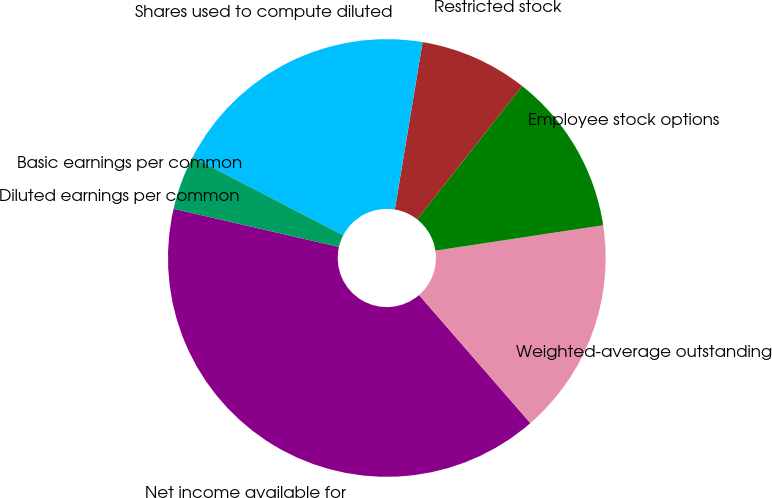Convert chart to OTSL. <chart><loc_0><loc_0><loc_500><loc_500><pie_chart><fcel>Net income available for<fcel>Weighted-average outstanding<fcel>Employee stock options<fcel>Restricted stock<fcel>Shares used to compute diluted<fcel>Basic earnings per common<fcel>Diluted earnings per common<nl><fcel>40.0%<fcel>16.0%<fcel>12.0%<fcel>8.0%<fcel>20.0%<fcel>4.0%<fcel>0.0%<nl></chart> 